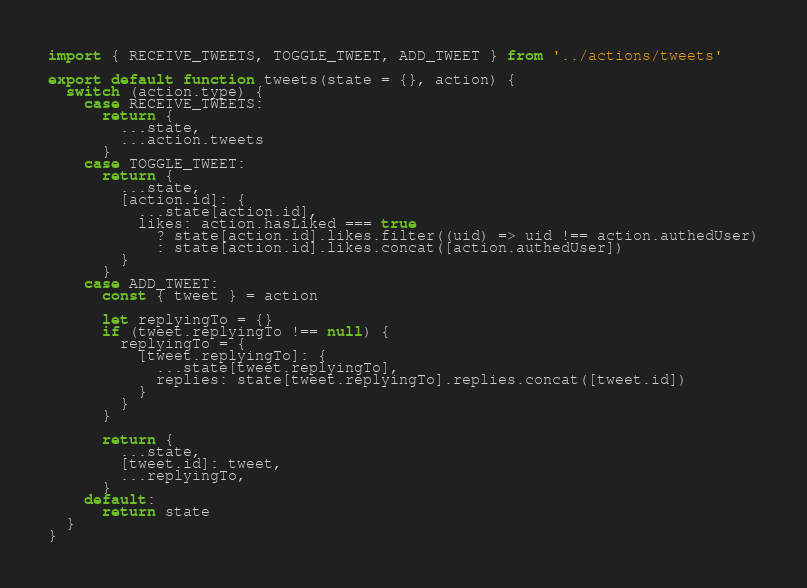<code> <loc_0><loc_0><loc_500><loc_500><_JavaScript_>import { RECEIVE_TWEETS, TOGGLE_TWEET, ADD_TWEET } from '../actions/tweets'

export default function tweets(state = {}, action) {
  switch (action.type) {
    case RECEIVE_TWEETS:
      return {
        ...state,
        ...action.tweets
      }
    case TOGGLE_TWEET:
      return {
        ...state,
        [action.id]: {
          ...state[action.id],
          likes: action.hasLiked === true
            ? state[action.id].likes.filter((uid) => uid !== action.authedUser)
            : state[action.id].likes.concat([action.authedUser])
        }
      }
    case ADD_TWEET:
      const { tweet } = action

      let replyingTo = {}
      if (tweet.replyingTo !== null) {
        replyingTo = {
          [tweet.replyingTo]: {
            ...state[tweet.replyingTo],
            replies: state[tweet.replyingTo].replies.concat([tweet.id])
          }
        }
      }

      return {
        ...state,
        [tweet.id]: tweet,
        ...replyingTo,
      }
    default:
      return state
  }
}</code> 